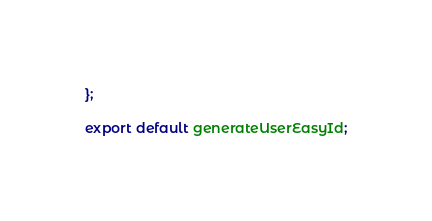<code> <loc_0><loc_0><loc_500><loc_500><_TypeScript_>};

export default generateUserEasyId;
</code> 